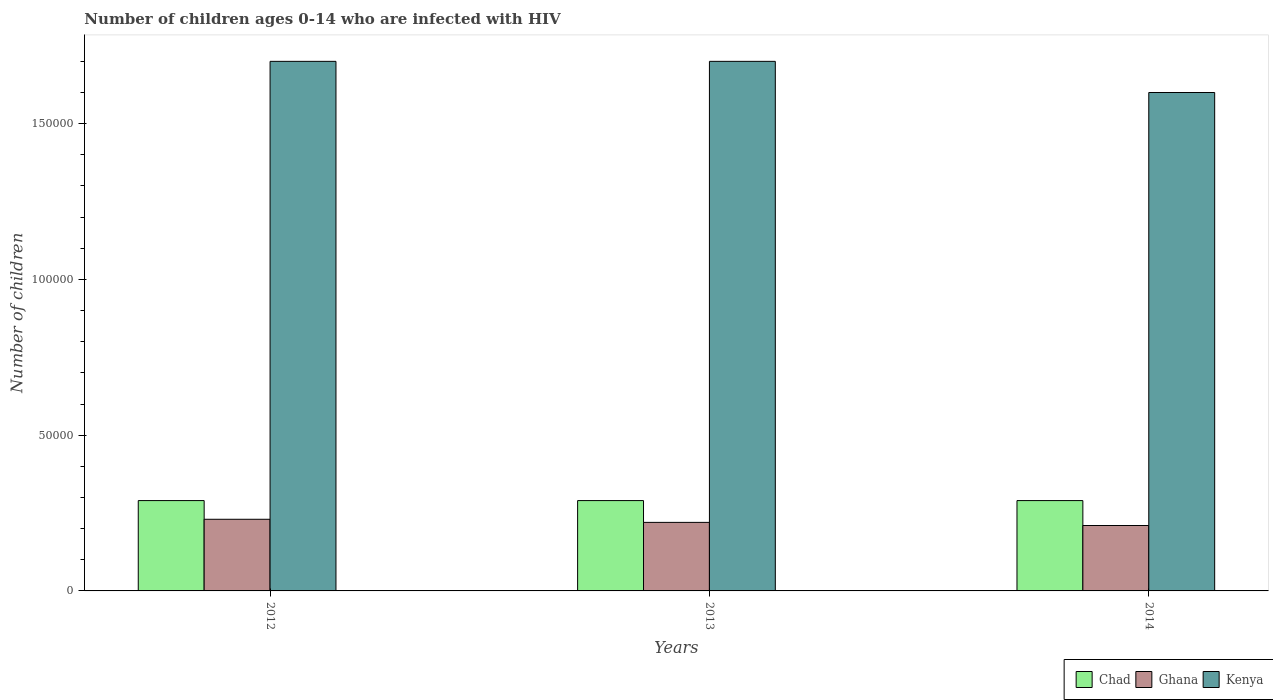How many groups of bars are there?
Offer a terse response. 3. Are the number of bars per tick equal to the number of legend labels?
Offer a terse response. Yes. How many bars are there on the 1st tick from the left?
Your answer should be compact. 3. How many bars are there on the 2nd tick from the right?
Provide a succinct answer. 3. What is the number of HIV infected children in Kenya in 2012?
Your response must be concise. 1.70e+05. Across all years, what is the maximum number of HIV infected children in Chad?
Offer a very short reply. 2.90e+04. Across all years, what is the minimum number of HIV infected children in Ghana?
Offer a very short reply. 2.10e+04. What is the total number of HIV infected children in Kenya in the graph?
Ensure brevity in your answer.  5.00e+05. What is the difference between the number of HIV infected children in Kenya in 2013 and that in 2014?
Ensure brevity in your answer.  10000. What is the difference between the number of HIV infected children in Ghana in 2014 and the number of HIV infected children in Kenya in 2012?
Offer a very short reply. -1.49e+05. What is the average number of HIV infected children in Chad per year?
Keep it short and to the point. 2.90e+04. In the year 2012, what is the difference between the number of HIV infected children in Kenya and number of HIV infected children in Chad?
Offer a very short reply. 1.41e+05. In how many years, is the number of HIV infected children in Chad greater than 90000?
Keep it short and to the point. 0. What is the ratio of the number of HIV infected children in Ghana in 2012 to that in 2014?
Keep it short and to the point. 1.1. What is the difference between the highest and the lowest number of HIV infected children in Kenya?
Ensure brevity in your answer.  10000. How many years are there in the graph?
Provide a succinct answer. 3. How many legend labels are there?
Provide a short and direct response. 3. How are the legend labels stacked?
Provide a short and direct response. Horizontal. What is the title of the graph?
Provide a short and direct response. Number of children ages 0-14 who are infected with HIV. Does "Rwanda" appear as one of the legend labels in the graph?
Ensure brevity in your answer.  No. What is the label or title of the X-axis?
Your response must be concise. Years. What is the label or title of the Y-axis?
Your response must be concise. Number of children. What is the Number of children in Chad in 2012?
Your response must be concise. 2.90e+04. What is the Number of children in Ghana in 2012?
Your response must be concise. 2.30e+04. What is the Number of children in Chad in 2013?
Keep it short and to the point. 2.90e+04. What is the Number of children in Ghana in 2013?
Give a very brief answer. 2.20e+04. What is the Number of children in Kenya in 2013?
Provide a short and direct response. 1.70e+05. What is the Number of children in Chad in 2014?
Keep it short and to the point. 2.90e+04. What is the Number of children of Ghana in 2014?
Offer a terse response. 2.10e+04. Across all years, what is the maximum Number of children of Chad?
Provide a short and direct response. 2.90e+04. Across all years, what is the maximum Number of children in Ghana?
Offer a terse response. 2.30e+04. Across all years, what is the maximum Number of children in Kenya?
Your answer should be very brief. 1.70e+05. Across all years, what is the minimum Number of children in Chad?
Keep it short and to the point. 2.90e+04. Across all years, what is the minimum Number of children in Ghana?
Provide a short and direct response. 2.10e+04. What is the total Number of children in Chad in the graph?
Offer a terse response. 8.70e+04. What is the total Number of children in Ghana in the graph?
Keep it short and to the point. 6.60e+04. What is the total Number of children of Kenya in the graph?
Make the answer very short. 5.00e+05. What is the difference between the Number of children in Kenya in 2012 and that in 2013?
Your response must be concise. 0. What is the difference between the Number of children in Ghana in 2012 and that in 2014?
Ensure brevity in your answer.  2000. What is the difference between the Number of children in Kenya in 2012 and that in 2014?
Offer a terse response. 10000. What is the difference between the Number of children in Chad in 2013 and that in 2014?
Your response must be concise. 0. What is the difference between the Number of children in Ghana in 2013 and that in 2014?
Your answer should be very brief. 1000. What is the difference between the Number of children of Kenya in 2013 and that in 2014?
Offer a very short reply. 10000. What is the difference between the Number of children in Chad in 2012 and the Number of children in Ghana in 2013?
Your answer should be compact. 7000. What is the difference between the Number of children of Chad in 2012 and the Number of children of Kenya in 2013?
Provide a short and direct response. -1.41e+05. What is the difference between the Number of children of Ghana in 2012 and the Number of children of Kenya in 2013?
Your answer should be compact. -1.47e+05. What is the difference between the Number of children in Chad in 2012 and the Number of children in Ghana in 2014?
Provide a short and direct response. 8000. What is the difference between the Number of children in Chad in 2012 and the Number of children in Kenya in 2014?
Give a very brief answer. -1.31e+05. What is the difference between the Number of children of Ghana in 2012 and the Number of children of Kenya in 2014?
Provide a short and direct response. -1.37e+05. What is the difference between the Number of children of Chad in 2013 and the Number of children of Ghana in 2014?
Give a very brief answer. 8000. What is the difference between the Number of children of Chad in 2013 and the Number of children of Kenya in 2014?
Offer a terse response. -1.31e+05. What is the difference between the Number of children in Ghana in 2013 and the Number of children in Kenya in 2014?
Give a very brief answer. -1.38e+05. What is the average Number of children of Chad per year?
Keep it short and to the point. 2.90e+04. What is the average Number of children of Ghana per year?
Offer a terse response. 2.20e+04. What is the average Number of children in Kenya per year?
Your answer should be compact. 1.67e+05. In the year 2012, what is the difference between the Number of children in Chad and Number of children in Ghana?
Your answer should be very brief. 6000. In the year 2012, what is the difference between the Number of children of Chad and Number of children of Kenya?
Make the answer very short. -1.41e+05. In the year 2012, what is the difference between the Number of children in Ghana and Number of children in Kenya?
Your answer should be compact. -1.47e+05. In the year 2013, what is the difference between the Number of children in Chad and Number of children in Ghana?
Offer a terse response. 7000. In the year 2013, what is the difference between the Number of children of Chad and Number of children of Kenya?
Offer a very short reply. -1.41e+05. In the year 2013, what is the difference between the Number of children of Ghana and Number of children of Kenya?
Keep it short and to the point. -1.48e+05. In the year 2014, what is the difference between the Number of children of Chad and Number of children of Ghana?
Your answer should be compact. 8000. In the year 2014, what is the difference between the Number of children of Chad and Number of children of Kenya?
Your answer should be very brief. -1.31e+05. In the year 2014, what is the difference between the Number of children in Ghana and Number of children in Kenya?
Provide a short and direct response. -1.39e+05. What is the ratio of the Number of children in Chad in 2012 to that in 2013?
Provide a succinct answer. 1. What is the ratio of the Number of children in Ghana in 2012 to that in 2013?
Offer a terse response. 1.05. What is the ratio of the Number of children of Kenya in 2012 to that in 2013?
Give a very brief answer. 1. What is the ratio of the Number of children in Chad in 2012 to that in 2014?
Provide a succinct answer. 1. What is the ratio of the Number of children of Ghana in 2012 to that in 2014?
Your answer should be very brief. 1.1. What is the ratio of the Number of children in Ghana in 2013 to that in 2014?
Your response must be concise. 1.05. What is the difference between the highest and the lowest Number of children of Ghana?
Your response must be concise. 2000. 